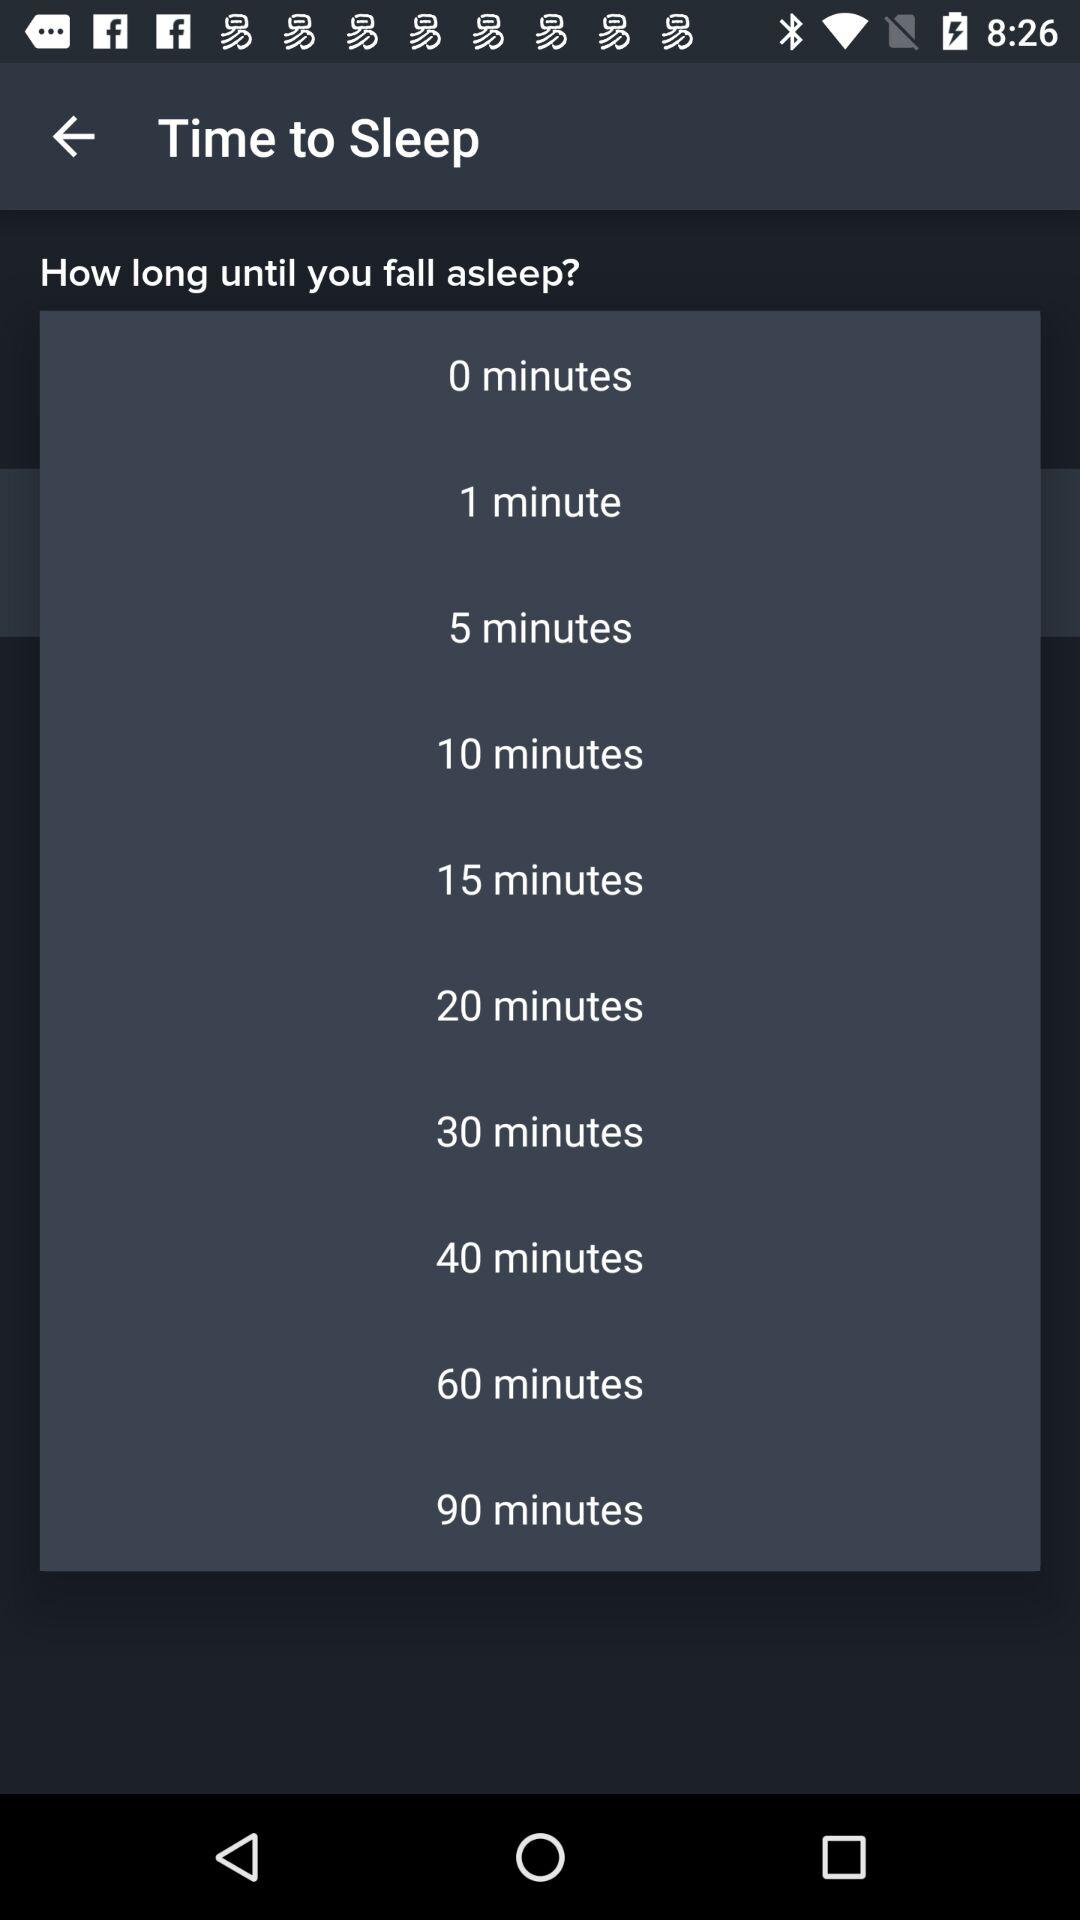How many minutes is the shortest time until I can fall asleep?
Answer the question using a single word or phrase. 0 minutes 